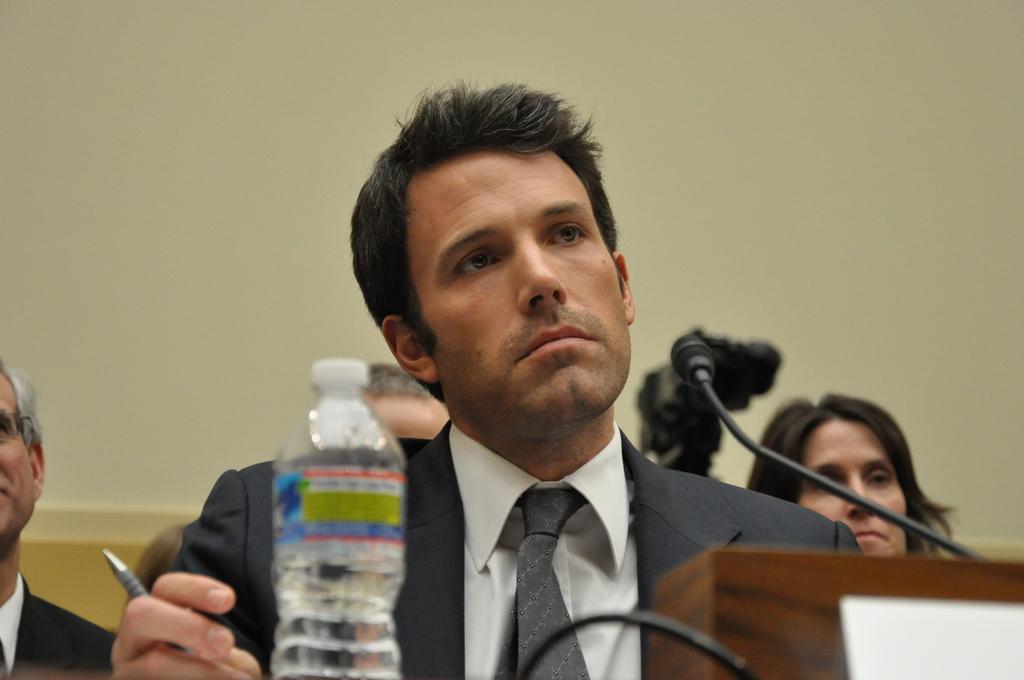How would you summarize this image in a sentence or two? A man is sitting in a conference room with few people behind him. 